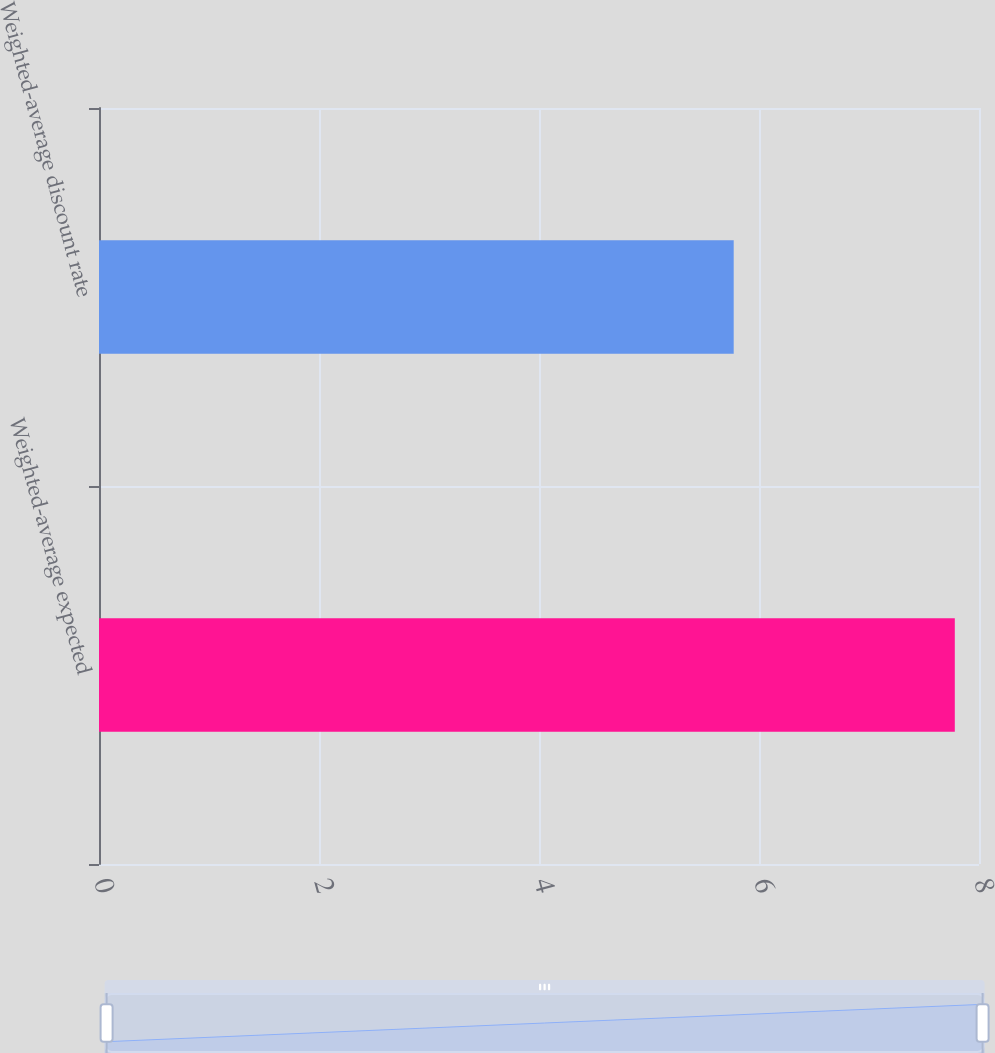Convert chart to OTSL. <chart><loc_0><loc_0><loc_500><loc_500><bar_chart><fcel>Weighted-average expected<fcel>Weighted-average discount rate<nl><fcel>7.78<fcel>5.77<nl></chart> 